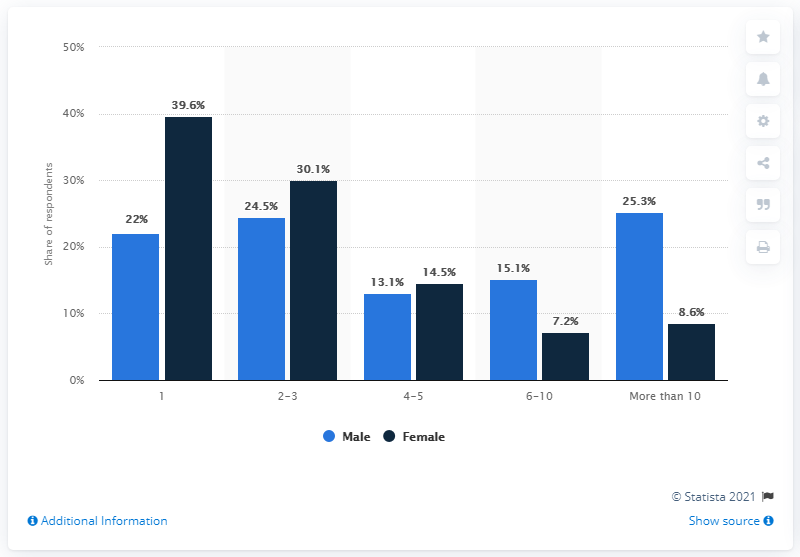Give some essential details in this illustration. In a survey of women, 39.6% reported having only one sexual partner in their lifetime. The percentage of females who had more than ten sex partners was 8.6%. According to the survey, 25.3% of male respondents reported having had more than ten sexual partners. 